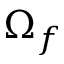Convert formula to latex. <formula><loc_0><loc_0><loc_500><loc_500>\Omega _ { f }</formula> 